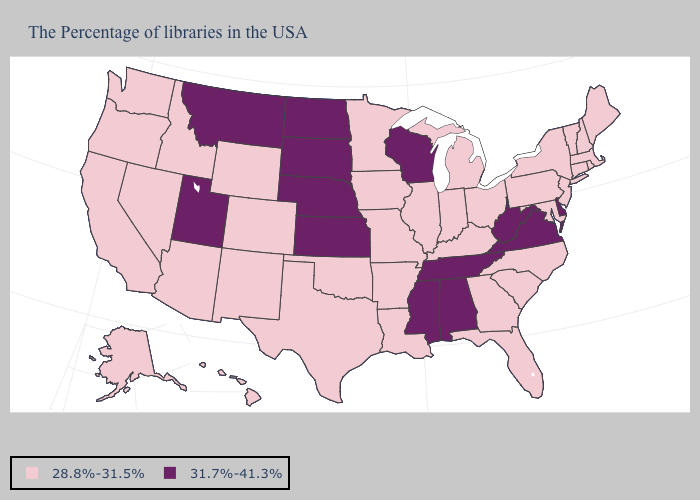Does the map have missing data?
Write a very short answer. No. What is the value of Alaska?
Concise answer only. 28.8%-31.5%. Does Connecticut have the same value as Arkansas?
Quick response, please. Yes. What is the value of Mississippi?
Quick response, please. 31.7%-41.3%. Name the states that have a value in the range 31.7%-41.3%?
Concise answer only. Delaware, Virginia, West Virginia, Alabama, Tennessee, Wisconsin, Mississippi, Kansas, Nebraska, South Dakota, North Dakota, Utah, Montana. Name the states that have a value in the range 31.7%-41.3%?
Give a very brief answer. Delaware, Virginia, West Virginia, Alabama, Tennessee, Wisconsin, Mississippi, Kansas, Nebraska, South Dakota, North Dakota, Utah, Montana. Among the states that border Virginia , does West Virginia have the lowest value?
Quick response, please. No. Is the legend a continuous bar?
Concise answer only. No. Does Washington have the lowest value in the USA?
Write a very short answer. Yes. What is the lowest value in the USA?
Concise answer only. 28.8%-31.5%. Among the states that border Maryland , does Pennsylvania have the highest value?
Concise answer only. No. Does Oklahoma have the same value as Georgia?
Answer briefly. Yes. Which states have the lowest value in the USA?
Give a very brief answer. Maine, Massachusetts, Rhode Island, New Hampshire, Vermont, Connecticut, New York, New Jersey, Maryland, Pennsylvania, North Carolina, South Carolina, Ohio, Florida, Georgia, Michigan, Kentucky, Indiana, Illinois, Louisiana, Missouri, Arkansas, Minnesota, Iowa, Oklahoma, Texas, Wyoming, Colorado, New Mexico, Arizona, Idaho, Nevada, California, Washington, Oregon, Alaska, Hawaii. Does Minnesota have the same value as Hawaii?
Concise answer only. Yes. 